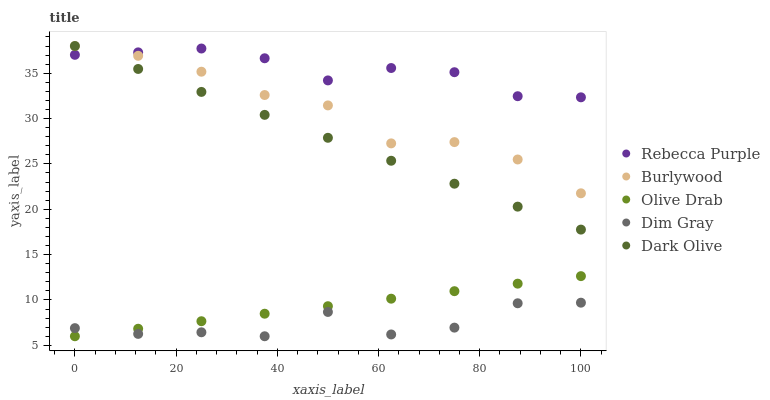Does Dim Gray have the minimum area under the curve?
Answer yes or no. Yes. Does Rebecca Purple have the maximum area under the curve?
Answer yes or no. Yes. Does Dark Olive have the minimum area under the curve?
Answer yes or no. No. Does Dark Olive have the maximum area under the curve?
Answer yes or no. No. Is Olive Drab the smoothest?
Answer yes or no. Yes. Is Dim Gray the roughest?
Answer yes or no. Yes. Is Dark Olive the smoothest?
Answer yes or no. No. Is Dark Olive the roughest?
Answer yes or no. No. Does Dim Gray have the lowest value?
Answer yes or no. Yes. Does Dark Olive have the lowest value?
Answer yes or no. No. Does Dark Olive have the highest value?
Answer yes or no. Yes. Does Dim Gray have the highest value?
Answer yes or no. No. Is Dim Gray less than Burlywood?
Answer yes or no. Yes. Is Burlywood greater than Olive Drab?
Answer yes or no. Yes. Does Rebecca Purple intersect Dark Olive?
Answer yes or no. Yes. Is Rebecca Purple less than Dark Olive?
Answer yes or no. No. Is Rebecca Purple greater than Dark Olive?
Answer yes or no. No. Does Dim Gray intersect Burlywood?
Answer yes or no. No. 